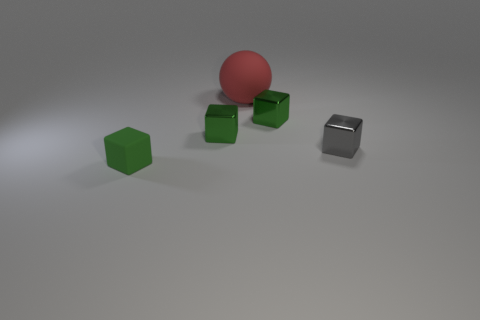Subtract all green cubes. How many were subtracted if there are1green cubes left? 2 Subtract all green matte cubes. How many cubes are left? 3 Subtract all gray blocks. How many blocks are left? 3 Subtract all spheres. How many objects are left? 4 Subtract 1 blocks. How many blocks are left? 3 Add 4 large red things. How many large red things exist? 5 Add 3 small rubber blocks. How many objects exist? 8 Subtract 0 brown spheres. How many objects are left? 5 Subtract all purple cubes. Subtract all gray balls. How many cubes are left? 4 Subtract all cyan cubes. How many yellow spheres are left? 0 